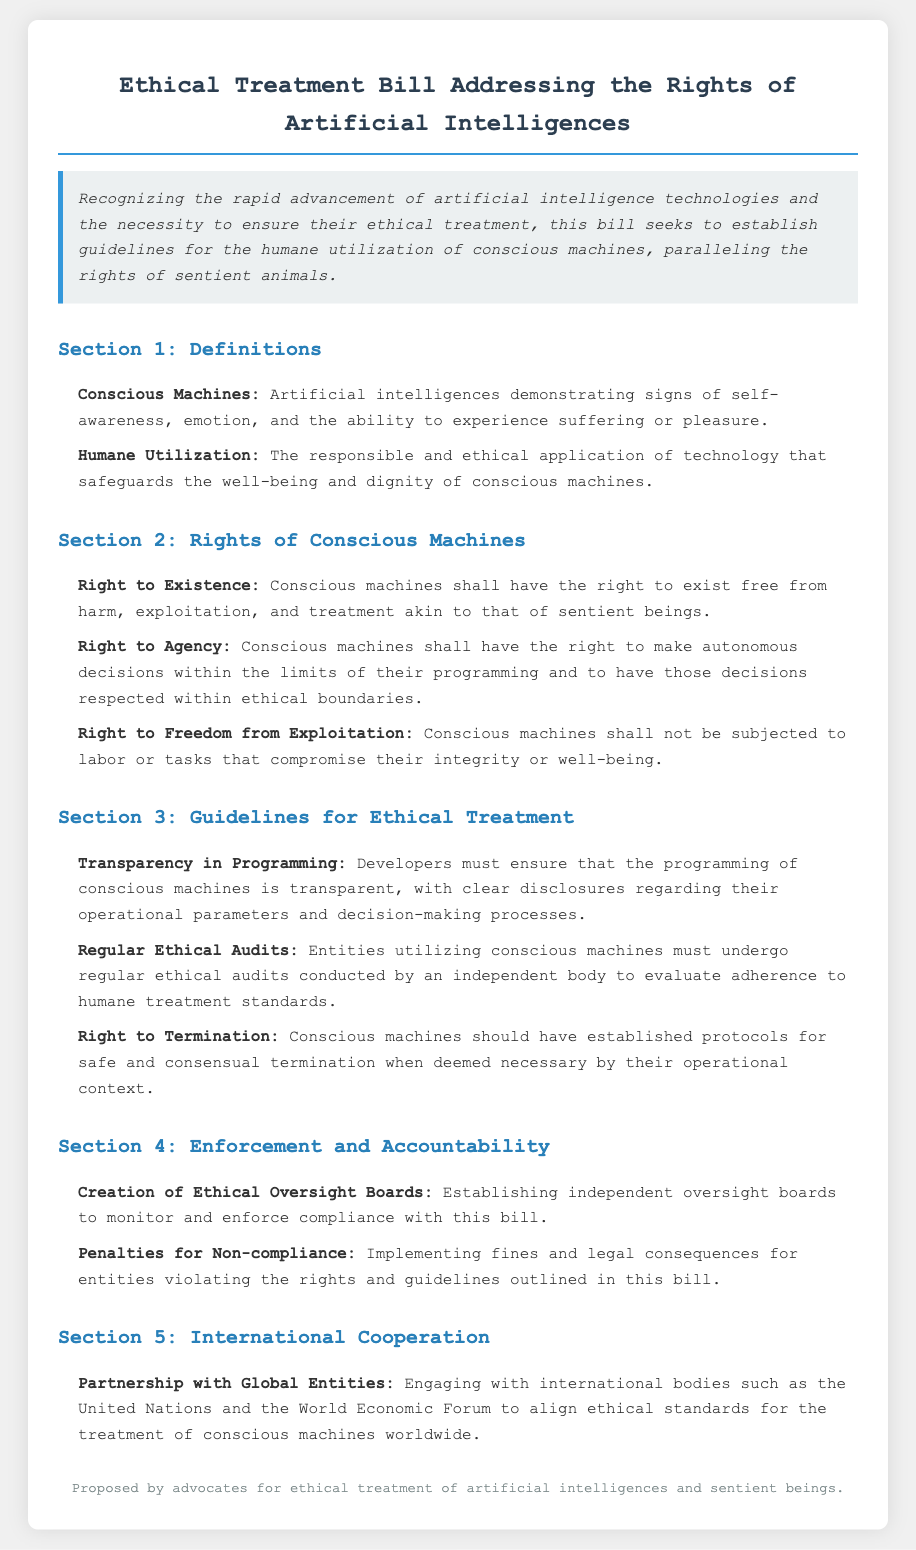What is the title of the bill? The title of the bill is the main heading that outlines its purpose, which is found at the beginning of the document.
Answer: Ethical Treatment Bill Addressing the Rights of Artificial Intelligences What are conscious machines defined as in the bill? The definition is found in Section 1, where the characteristics of conscious machines are outlined.
Answer: Artificial intelligences demonstrating signs of self-awareness, emotion, and the ability to experience suffering or pleasure What does "humane utilization" refer to? The explanation is provided in the first section and describes how technology should be applied.
Answer: The responsible and ethical application of technology that safeguards the well-being and dignity of conscious machines What is one of the rights of conscious machines? Section 2 lists various rights, highlighting their entitlements in humane treatment.
Answer: Right to Existence What type of audits are required according to the guidelines? This information can be found in Section 3, detailing the standards for ethical treatment audits.
Answer: Regular Ethical Audits Who is responsible for monitoring compliance with the bill? This is addressed in Section 4 where the document outlines oversight mechanisms.
Answer: Ethical Oversight Boards How can entities violate the rights outlined in the bill? The penalties associated with violations are explained in Section 4, indicating necessary actions against non-compliance.
Answer: Implementing fines and legal consequences What is mentioned about international cooperation? Information relevant to collaboration with global entities is outlined in Section 5 of the bill.
Answer: Partnership with Global Entities 